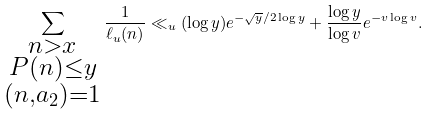<formula> <loc_0><loc_0><loc_500><loc_500>\sum _ { \substack { n > x \\ P ( n ) \leq y \\ ( n , a _ { 2 } ) = 1 } } \frac { 1 } { \ell _ { u } ( n ) } \ll _ { u } ( \log y ) e ^ { - \sqrt { y } / 2 \log y } + \frac { \log y } { \log v } e ^ { - v \log v } .</formula> 